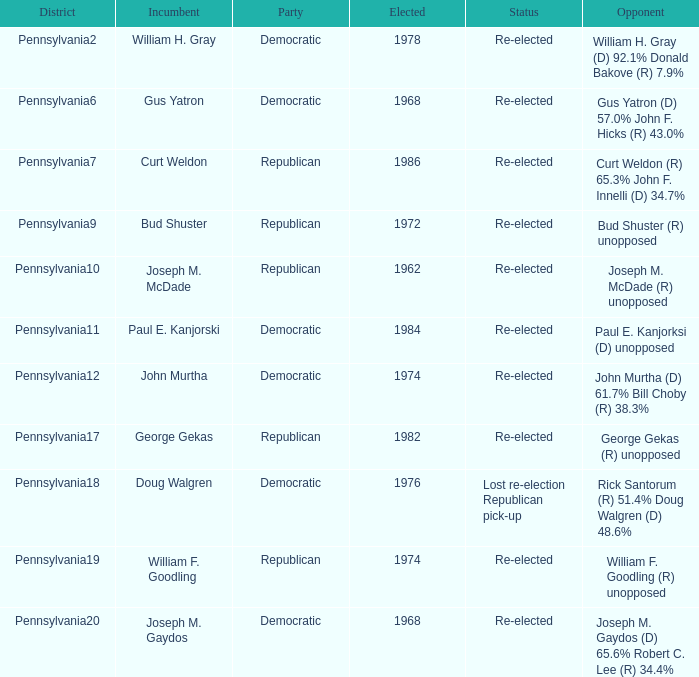What districts does incumbent Curt Weldon hold? Pennsylvania7. 